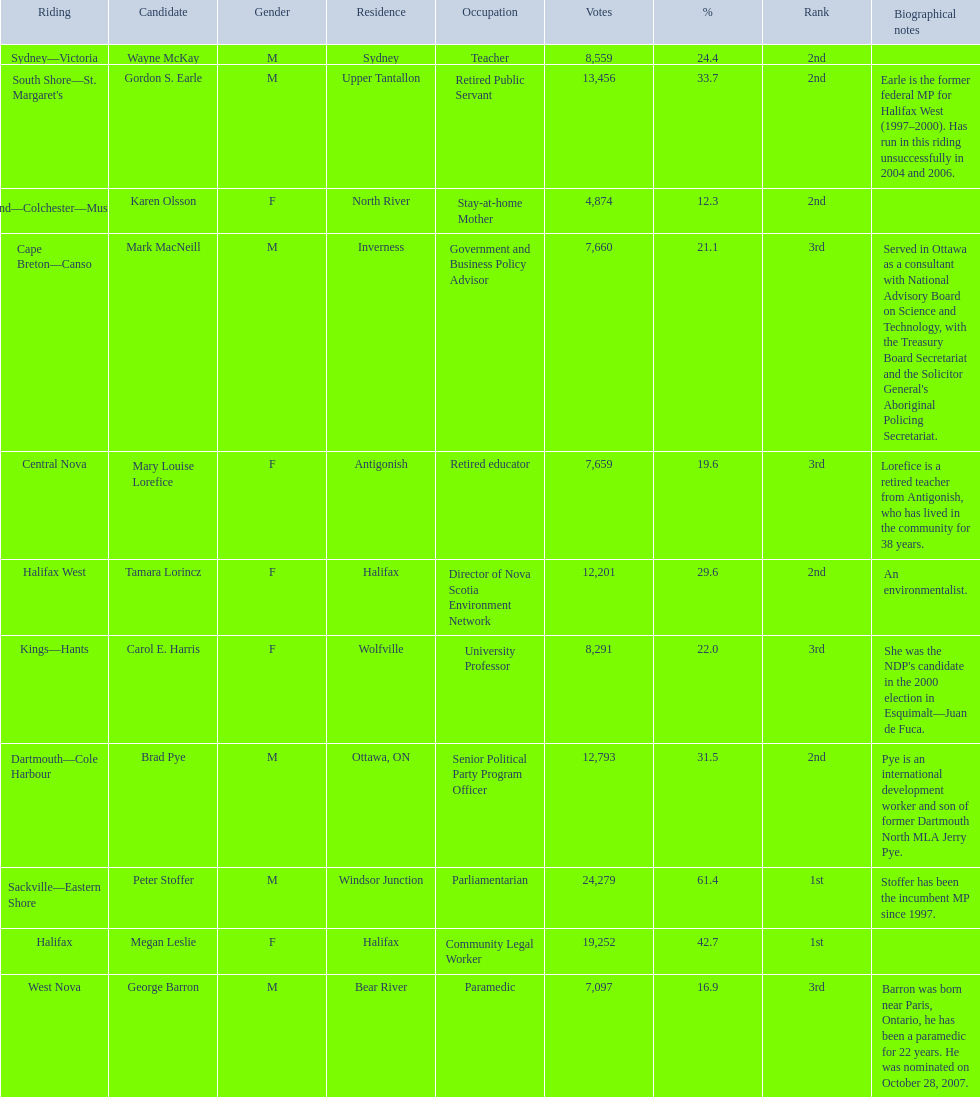Which candidates have the four lowest amount of votes Mark MacNeill, Mary Louise Lorefice, Karen Olsson, George Barron. Out of the following, who has the third most? Mark MacNeill. 